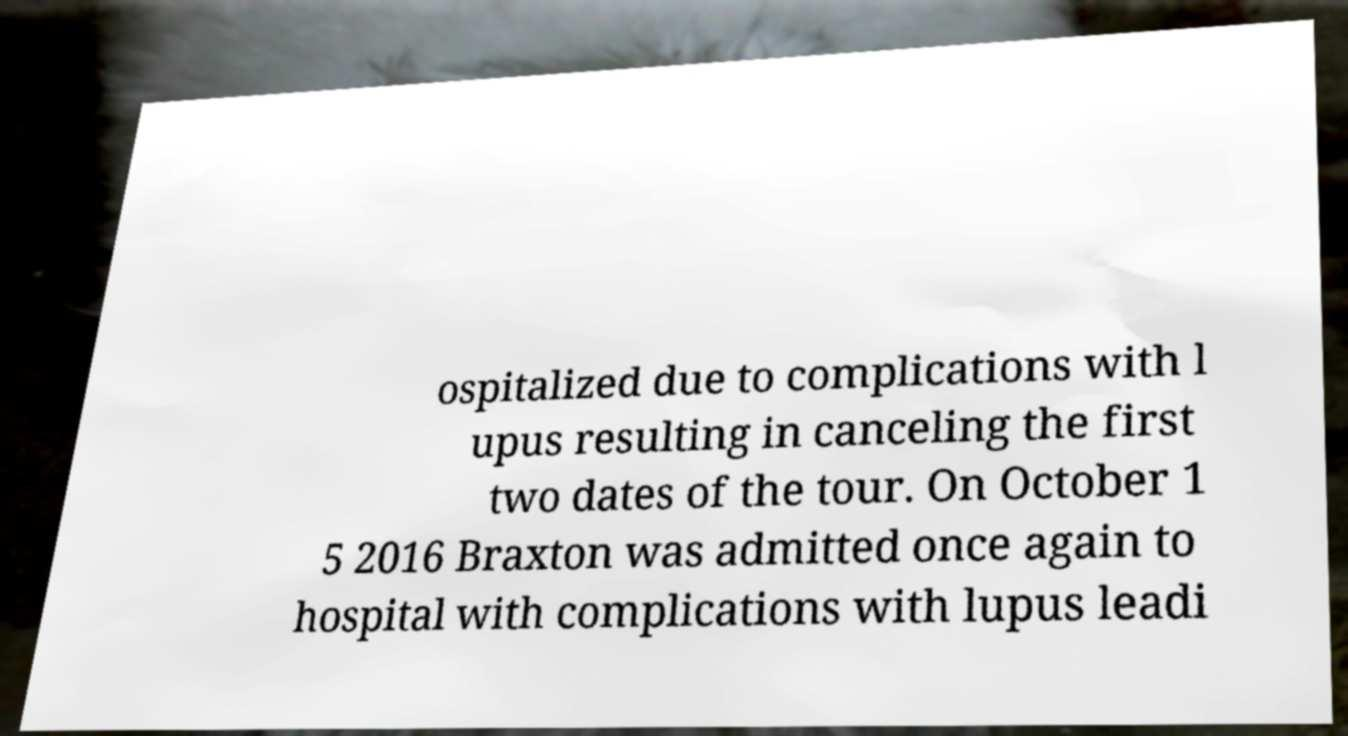Could you extract and type out the text from this image? ospitalized due to complications with l upus resulting in canceling the first two dates of the tour. On October 1 5 2016 Braxton was admitted once again to hospital with complications with lupus leadi 